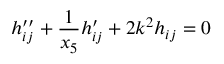Convert formula to latex. <formula><loc_0><loc_0><loc_500><loc_500>h _ { i j } ^ { \prime \prime } + \frac { 1 } { x _ { 5 } } h _ { i j } ^ { \prime } + 2 k ^ { 2 } h _ { i j } = 0</formula> 